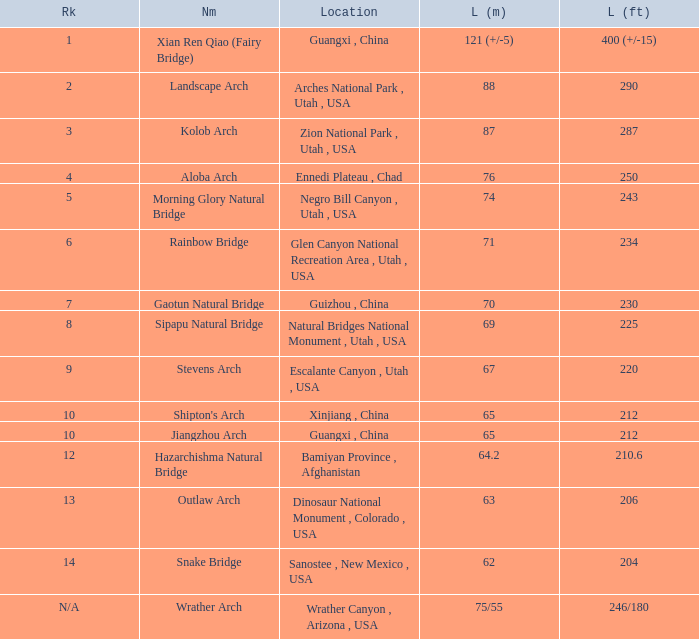What is the rank of the arch with a length in meters of 75/55? N/A. 